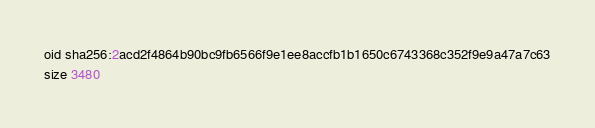Convert code to text. <code><loc_0><loc_0><loc_500><loc_500><_C++_>oid sha256:2acd2f4864b90bc9fb6566f9e1ee8accfb1b1650c6743368c352f9e9a47a7c63
size 3480
</code> 